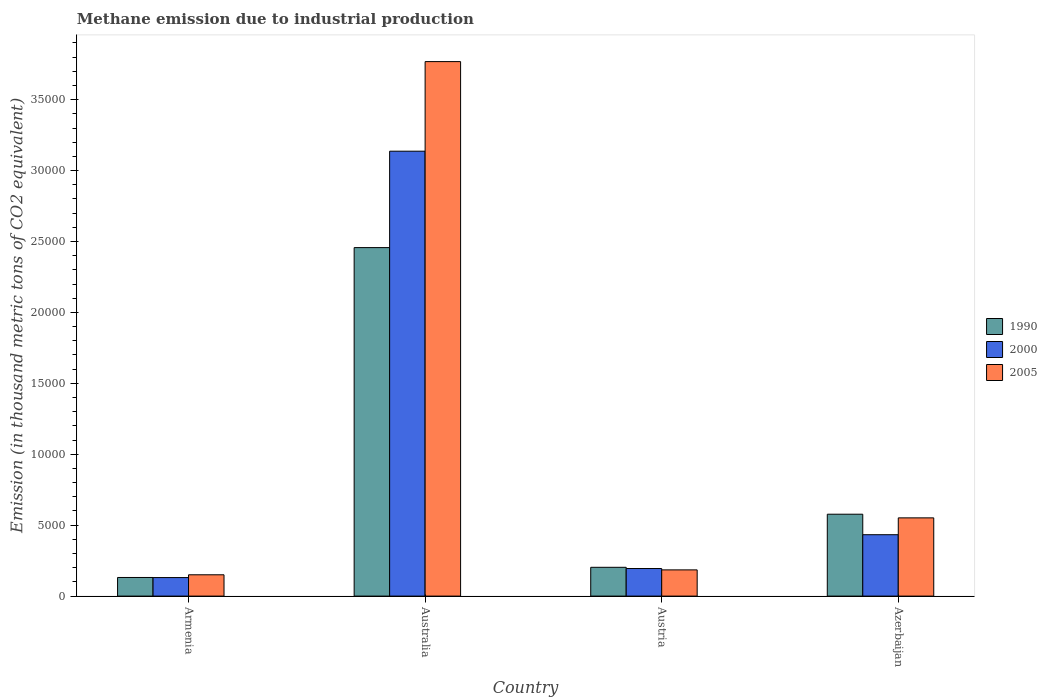How many different coloured bars are there?
Offer a terse response. 3. How many groups of bars are there?
Your answer should be compact. 4. Are the number of bars per tick equal to the number of legend labels?
Ensure brevity in your answer.  Yes. How many bars are there on the 1st tick from the left?
Make the answer very short. 3. How many bars are there on the 2nd tick from the right?
Ensure brevity in your answer.  3. What is the label of the 2nd group of bars from the left?
Your answer should be very brief. Australia. What is the amount of methane emitted in 2005 in Australia?
Provide a short and direct response. 3.77e+04. Across all countries, what is the maximum amount of methane emitted in 2005?
Ensure brevity in your answer.  3.77e+04. Across all countries, what is the minimum amount of methane emitted in 2000?
Your answer should be compact. 1306.1. In which country was the amount of methane emitted in 1990 minimum?
Provide a succinct answer. Armenia. What is the total amount of methane emitted in 2000 in the graph?
Provide a succinct answer. 3.89e+04. What is the difference between the amount of methane emitted in 2000 in Armenia and that in Australia?
Provide a succinct answer. -3.01e+04. What is the difference between the amount of methane emitted in 2000 in Armenia and the amount of methane emitted in 1990 in Azerbaijan?
Your answer should be compact. -4466.9. What is the average amount of methane emitted in 1990 per country?
Keep it short and to the point. 8421.75. What is the difference between the amount of methane emitted of/in 2000 and amount of methane emitted of/in 1990 in Azerbaijan?
Your response must be concise. -1445.2. In how many countries, is the amount of methane emitted in 1990 greater than 23000 thousand metric tons?
Offer a terse response. 1. What is the ratio of the amount of methane emitted in 2000 in Armenia to that in Azerbaijan?
Keep it short and to the point. 0.3. What is the difference between the highest and the second highest amount of methane emitted in 1990?
Provide a succinct answer. 1.88e+04. What is the difference between the highest and the lowest amount of methane emitted in 2000?
Keep it short and to the point. 3.01e+04. In how many countries, is the amount of methane emitted in 2005 greater than the average amount of methane emitted in 2005 taken over all countries?
Your response must be concise. 1. Is the sum of the amount of methane emitted in 1990 in Austria and Azerbaijan greater than the maximum amount of methane emitted in 2005 across all countries?
Your answer should be compact. No. What does the 1st bar from the left in Azerbaijan represents?
Provide a short and direct response. 1990. What does the 3rd bar from the right in Austria represents?
Your answer should be compact. 1990. How many countries are there in the graph?
Provide a succinct answer. 4. What is the difference between two consecutive major ticks on the Y-axis?
Offer a terse response. 5000. Does the graph contain any zero values?
Provide a succinct answer. No. How many legend labels are there?
Offer a very short reply. 3. How are the legend labels stacked?
Offer a terse response. Vertical. What is the title of the graph?
Offer a very short reply. Methane emission due to industrial production. Does "1980" appear as one of the legend labels in the graph?
Your response must be concise. No. What is the label or title of the X-axis?
Offer a terse response. Country. What is the label or title of the Y-axis?
Give a very brief answer. Emission (in thousand metric tons of CO2 equivalent). What is the Emission (in thousand metric tons of CO2 equivalent) of 1990 in Armenia?
Your response must be concise. 1313.2. What is the Emission (in thousand metric tons of CO2 equivalent) in 2000 in Armenia?
Your response must be concise. 1306.1. What is the Emission (in thousand metric tons of CO2 equivalent) in 2005 in Armenia?
Your response must be concise. 1502.5. What is the Emission (in thousand metric tons of CO2 equivalent) of 1990 in Australia?
Offer a very short reply. 2.46e+04. What is the Emission (in thousand metric tons of CO2 equivalent) of 2000 in Australia?
Offer a terse response. 3.14e+04. What is the Emission (in thousand metric tons of CO2 equivalent) of 2005 in Australia?
Offer a terse response. 3.77e+04. What is the Emission (in thousand metric tons of CO2 equivalent) of 1990 in Austria?
Provide a short and direct response. 2030.6. What is the Emission (in thousand metric tons of CO2 equivalent) in 2000 in Austria?
Keep it short and to the point. 1944.7. What is the Emission (in thousand metric tons of CO2 equivalent) in 2005 in Austria?
Give a very brief answer. 1848.3. What is the Emission (in thousand metric tons of CO2 equivalent) of 1990 in Azerbaijan?
Make the answer very short. 5773. What is the Emission (in thousand metric tons of CO2 equivalent) in 2000 in Azerbaijan?
Provide a succinct answer. 4327.8. What is the Emission (in thousand metric tons of CO2 equivalent) in 2005 in Azerbaijan?
Make the answer very short. 5515.2. Across all countries, what is the maximum Emission (in thousand metric tons of CO2 equivalent) in 1990?
Your answer should be very brief. 2.46e+04. Across all countries, what is the maximum Emission (in thousand metric tons of CO2 equivalent) in 2000?
Provide a short and direct response. 3.14e+04. Across all countries, what is the maximum Emission (in thousand metric tons of CO2 equivalent) of 2005?
Your response must be concise. 3.77e+04. Across all countries, what is the minimum Emission (in thousand metric tons of CO2 equivalent) of 1990?
Provide a short and direct response. 1313.2. Across all countries, what is the minimum Emission (in thousand metric tons of CO2 equivalent) of 2000?
Your answer should be very brief. 1306.1. Across all countries, what is the minimum Emission (in thousand metric tons of CO2 equivalent) of 2005?
Ensure brevity in your answer.  1502.5. What is the total Emission (in thousand metric tons of CO2 equivalent) in 1990 in the graph?
Offer a terse response. 3.37e+04. What is the total Emission (in thousand metric tons of CO2 equivalent) of 2000 in the graph?
Provide a succinct answer. 3.89e+04. What is the total Emission (in thousand metric tons of CO2 equivalent) in 2005 in the graph?
Make the answer very short. 4.66e+04. What is the difference between the Emission (in thousand metric tons of CO2 equivalent) of 1990 in Armenia and that in Australia?
Your answer should be very brief. -2.33e+04. What is the difference between the Emission (in thousand metric tons of CO2 equivalent) of 2000 in Armenia and that in Australia?
Your answer should be compact. -3.01e+04. What is the difference between the Emission (in thousand metric tons of CO2 equivalent) in 2005 in Armenia and that in Australia?
Provide a short and direct response. -3.62e+04. What is the difference between the Emission (in thousand metric tons of CO2 equivalent) of 1990 in Armenia and that in Austria?
Your answer should be very brief. -717.4. What is the difference between the Emission (in thousand metric tons of CO2 equivalent) of 2000 in Armenia and that in Austria?
Offer a very short reply. -638.6. What is the difference between the Emission (in thousand metric tons of CO2 equivalent) in 2005 in Armenia and that in Austria?
Ensure brevity in your answer.  -345.8. What is the difference between the Emission (in thousand metric tons of CO2 equivalent) in 1990 in Armenia and that in Azerbaijan?
Your answer should be very brief. -4459.8. What is the difference between the Emission (in thousand metric tons of CO2 equivalent) in 2000 in Armenia and that in Azerbaijan?
Make the answer very short. -3021.7. What is the difference between the Emission (in thousand metric tons of CO2 equivalent) of 2005 in Armenia and that in Azerbaijan?
Give a very brief answer. -4012.7. What is the difference between the Emission (in thousand metric tons of CO2 equivalent) in 1990 in Australia and that in Austria?
Your answer should be very brief. 2.25e+04. What is the difference between the Emission (in thousand metric tons of CO2 equivalent) in 2000 in Australia and that in Austria?
Ensure brevity in your answer.  2.94e+04. What is the difference between the Emission (in thousand metric tons of CO2 equivalent) in 2005 in Australia and that in Austria?
Ensure brevity in your answer.  3.58e+04. What is the difference between the Emission (in thousand metric tons of CO2 equivalent) in 1990 in Australia and that in Azerbaijan?
Keep it short and to the point. 1.88e+04. What is the difference between the Emission (in thousand metric tons of CO2 equivalent) in 2000 in Australia and that in Azerbaijan?
Ensure brevity in your answer.  2.70e+04. What is the difference between the Emission (in thousand metric tons of CO2 equivalent) of 2005 in Australia and that in Azerbaijan?
Your answer should be compact. 3.22e+04. What is the difference between the Emission (in thousand metric tons of CO2 equivalent) in 1990 in Austria and that in Azerbaijan?
Ensure brevity in your answer.  -3742.4. What is the difference between the Emission (in thousand metric tons of CO2 equivalent) of 2000 in Austria and that in Azerbaijan?
Make the answer very short. -2383.1. What is the difference between the Emission (in thousand metric tons of CO2 equivalent) in 2005 in Austria and that in Azerbaijan?
Provide a short and direct response. -3666.9. What is the difference between the Emission (in thousand metric tons of CO2 equivalent) in 1990 in Armenia and the Emission (in thousand metric tons of CO2 equivalent) in 2000 in Australia?
Ensure brevity in your answer.  -3.01e+04. What is the difference between the Emission (in thousand metric tons of CO2 equivalent) of 1990 in Armenia and the Emission (in thousand metric tons of CO2 equivalent) of 2005 in Australia?
Provide a short and direct response. -3.64e+04. What is the difference between the Emission (in thousand metric tons of CO2 equivalent) of 2000 in Armenia and the Emission (in thousand metric tons of CO2 equivalent) of 2005 in Australia?
Your answer should be very brief. -3.64e+04. What is the difference between the Emission (in thousand metric tons of CO2 equivalent) in 1990 in Armenia and the Emission (in thousand metric tons of CO2 equivalent) in 2000 in Austria?
Your response must be concise. -631.5. What is the difference between the Emission (in thousand metric tons of CO2 equivalent) in 1990 in Armenia and the Emission (in thousand metric tons of CO2 equivalent) in 2005 in Austria?
Your answer should be compact. -535.1. What is the difference between the Emission (in thousand metric tons of CO2 equivalent) in 2000 in Armenia and the Emission (in thousand metric tons of CO2 equivalent) in 2005 in Austria?
Provide a short and direct response. -542.2. What is the difference between the Emission (in thousand metric tons of CO2 equivalent) in 1990 in Armenia and the Emission (in thousand metric tons of CO2 equivalent) in 2000 in Azerbaijan?
Keep it short and to the point. -3014.6. What is the difference between the Emission (in thousand metric tons of CO2 equivalent) in 1990 in Armenia and the Emission (in thousand metric tons of CO2 equivalent) in 2005 in Azerbaijan?
Offer a very short reply. -4202. What is the difference between the Emission (in thousand metric tons of CO2 equivalent) of 2000 in Armenia and the Emission (in thousand metric tons of CO2 equivalent) of 2005 in Azerbaijan?
Your response must be concise. -4209.1. What is the difference between the Emission (in thousand metric tons of CO2 equivalent) of 1990 in Australia and the Emission (in thousand metric tons of CO2 equivalent) of 2000 in Austria?
Make the answer very short. 2.26e+04. What is the difference between the Emission (in thousand metric tons of CO2 equivalent) of 1990 in Australia and the Emission (in thousand metric tons of CO2 equivalent) of 2005 in Austria?
Make the answer very short. 2.27e+04. What is the difference between the Emission (in thousand metric tons of CO2 equivalent) in 2000 in Australia and the Emission (in thousand metric tons of CO2 equivalent) in 2005 in Austria?
Offer a terse response. 2.95e+04. What is the difference between the Emission (in thousand metric tons of CO2 equivalent) of 1990 in Australia and the Emission (in thousand metric tons of CO2 equivalent) of 2000 in Azerbaijan?
Your answer should be very brief. 2.02e+04. What is the difference between the Emission (in thousand metric tons of CO2 equivalent) of 1990 in Australia and the Emission (in thousand metric tons of CO2 equivalent) of 2005 in Azerbaijan?
Provide a succinct answer. 1.91e+04. What is the difference between the Emission (in thousand metric tons of CO2 equivalent) of 2000 in Australia and the Emission (in thousand metric tons of CO2 equivalent) of 2005 in Azerbaijan?
Keep it short and to the point. 2.59e+04. What is the difference between the Emission (in thousand metric tons of CO2 equivalent) of 1990 in Austria and the Emission (in thousand metric tons of CO2 equivalent) of 2000 in Azerbaijan?
Your answer should be compact. -2297.2. What is the difference between the Emission (in thousand metric tons of CO2 equivalent) of 1990 in Austria and the Emission (in thousand metric tons of CO2 equivalent) of 2005 in Azerbaijan?
Ensure brevity in your answer.  -3484.6. What is the difference between the Emission (in thousand metric tons of CO2 equivalent) in 2000 in Austria and the Emission (in thousand metric tons of CO2 equivalent) in 2005 in Azerbaijan?
Make the answer very short. -3570.5. What is the average Emission (in thousand metric tons of CO2 equivalent) in 1990 per country?
Provide a succinct answer. 8421.75. What is the average Emission (in thousand metric tons of CO2 equivalent) in 2000 per country?
Your answer should be very brief. 9736.65. What is the average Emission (in thousand metric tons of CO2 equivalent) in 2005 per country?
Provide a short and direct response. 1.16e+04. What is the difference between the Emission (in thousand metric tons of CO2 equivalent) of 1990 and Emission (in thousand metric tons of CO2 equivalent) of 2000 in Armenia?
Give a very brief answer. 7.1. What is the difference between the Emission (in thousand metric tons of CO2 equivalent) of 1990 and Emission (in thousand metric tons of CO2 equivalent) of 2005 in Armenia?
Offer a very short reply. -189.3. What is the difference between the Emission (in thousand metric tons of CO2 equivalent) in 2000 and Emission (in thousand metric tons of CO2 equivalent) in 2005 in Armenia?
Ensure brevity in your answer.  -196.4. What is the difference between the Emission (in thousand metric tons of CO2 equivalent) of 1990 and Emission (in thousand metric tons of CO2 equivalent) of 2000 in Australia?
Your response must be concise. -6797.8. What is the difference between the Emission (in thousand metric tons of CO2 equivalent) in 1990 and Emission (in thousand metric tons of CO2 equivalent) in 2005 in Australia?
Provide a short and direct response. -1.31e+04. What is the difference between the Emission (in thousand metric tons of CO2 equivalent) of 2000 and Emission (in thousand metric tons of CO2 equivalent) of 2005 in Australia?
Offer a very short reply. -6316.4. What is the difference between the Emission (in thousand metric tons of CO2 equivalent) of 1990 and Emission (in thousand metric tons of CO2 equivalent) of 2000 in Austria?
Make the answer very short. 85.9. What is the difference between the Emission (in thousand metric tons of CO2 equivalent) of 1990 and Emission (in thousand metric tons of CO2 equivalent) of 2005 in Austria?
Offer a very short reply. 182.3. What is the difference between the Emission (in thousand metric tons of CO2 equivalent) of 2000 and Emission (in thousand metric tons of CO2 equivalent) of 2005 in Austria?
Offer a terse response. 96.4. What is the difference between the Emission (in thousand metric tons of CO2 equivalent) of 1990 and Emission (in thousand metric tons of CO2 equivalent) of 2000 in Azerbaijan?
Offer a very short reply. 1445.2. What is the difference between the Emission (in thousand metric tons of CO2 equivalent) in 1990 and Emission (in thousand metric tons of CO2 equivalent) in 2005 in Azerbaijan?
Your response must be concise. 257.8. What is the difference between the Emission (in thousand metric tons of CO2 equivalent) in 2000 and Emission (in thousand metric tons of CO2 equivalent) in 2005 in Azerbaijan?
Provide a short and direct response. -1187.4. What is the ratio of the Emission (in thousand metric tons of CO2 equivalent) of 1990 in Armenia to that in Australia?
Give a very brief answer. 0.05. What is the ratio of the Emission (in thousand metric tons of CO2 equivalent) in 2000 in Armenia to that in Australia?
Offer a very short reply. 0.04. What is the ratio of the Emission (in thousand metric tons of CO2 equivalent) of 2005 in Armenia to that in Australia?
Provide a short and direct response. 0.04. What is the ratio of the Emission (in thousand metric tons of CO2 equivalent) in 1990 in Armenia to that in Austria?
Provide a succinct answer. 0.65. What is the ratio of the Emission (in thousand metric tons of CO2 equivalent) in 2000 in Armenia to that in Austria?
Offer a very short reply. 0.67. What is the ratio of the Emission (in thousand metric tons of CO2 equivalent) of 2005 in Armenia to that in Austria?
Offer a terse response. 0.81. What is the ratio of the Emission (in thousand metric tons of CO2 equivalent) in 1990 in Armenia to that in Azerbaijan?
Your answer should be compact. 0.23. What is the ratio of the Emission (in thousand metric tons of CO2 equivalent) of 2000 in Armenia to that in Azerbaijan?
Provide a succinct answer. 0.3. What is the ratio of the Emission (in thousand metric tons of CO2 equivalent) of 2005 in Armenia to that in Azerbaijan?
Offer a very short reply. 0.27. What is the ratio of the Emission (in thousand metric tons of CO2 equivalent) in 2000 in Australia to that in Austria?
Offer a very short reply. 16.13. What is the ratio of the Emission (in thousand metric tons of CO2 equivalent) in 2005 in Australia to that in Austria?
Give a very brief answer. 20.39. What is the ratio of the Emission (in thousand metric tons of CO2 equivalent) in 1990 in Australia to that in Azerbaijan?
Your answer should be very brief. 4.26. What is the ratio of the Emission (in thousand metric tons of CO2 equivalent) of 2000 in Australia to that in Azerbaijan?
Keep it short and to the point. 7.25. What is the ratio of the Emission (in thousand metric tons of CO2 equivalent) in 2005 in Australia to that in Azerbaijan?
Provide a short and direct response. 6.83. What is the ratio of the Emission (in thousand metric tons of CO2 equivalent) of 1990 in Austria to that in Azerbaijan?
Provide a short and direct response. 0.35. What is the ratio of the Emission (in thousand metric tons of CO2 equivalent) in 2000 in Austria to that in Azerbaijan?
Ensure brevity in your answer.  0.45. What is the ratio of the Emission (in thousand metric tons of CO2 equivalent) of 2005 in Austria to that in Azerbaijan?
Make the answer very short. 0.34. What is the difference between the highest and the second highest Emission (in thousand metric tons of CO2 equivalent) of 1990?
Make the answer very short. 1.88e+04. What is the difference between the highest and the second highest Emission (in thousand metric tons of CO2 equivalent) of 2000?
Keep it short and to the point. 2.70e+04. What is the difference between the highest and the second highest Emission (in thousand metric tons of CO2 equivalent) of 2005?
Make the answer very short. 3.22e+04. What is the difference between the highest and the lowest Emission (in thousand metric tons of CO2 equivalent) of 1990?
Ensure brevity in your answer.  2.33e+04. What is the difference between the highest and the lowest Emission (in thousand metric tons of CO2 equivalent) in 2000?
Your answer should be very brief. 3.01e+04. What is the difference between the highest and the lowest Emission (in thousand metric tons of CO2 equivalent) in 2005?
Offer a very short reply. 3.62e+04. 